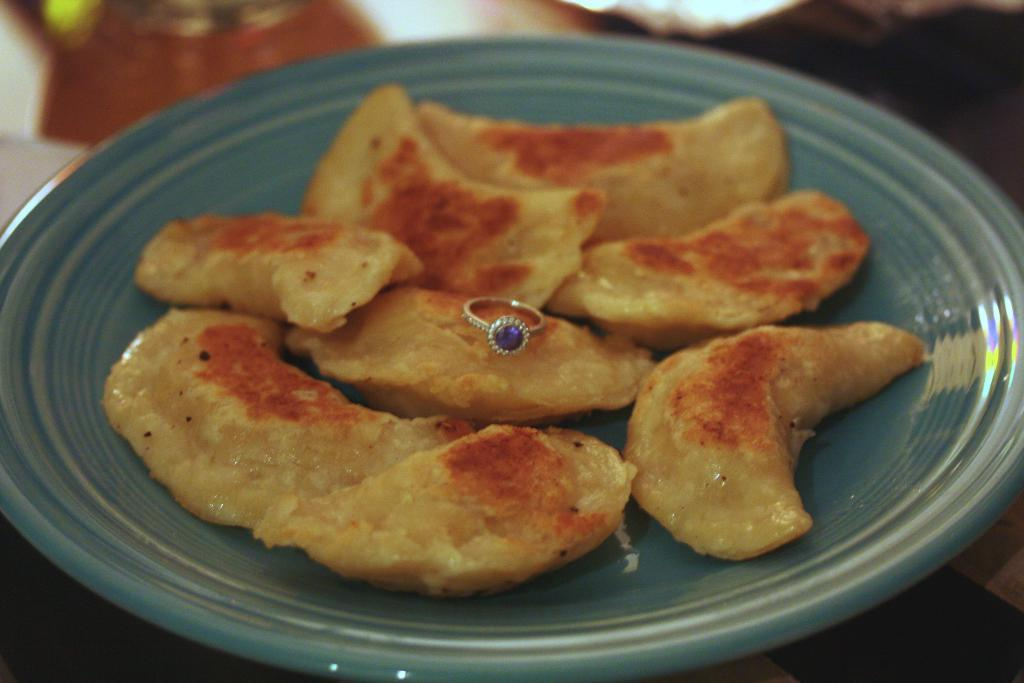What is on the plate that is visible in the image? There is a plate with food in the image. Can you describe the appearance of the food? The food has brown and orange colors. What color is the plate? The plate is green. How would you describe the background of the image? The background of the image is blurred. What type of waste is being produced by the farmer in the image? There is no farmer or waste present in the image. Which direction is the food pointing towards in the image? The food on the plate is not pointing in any direction; it is stationary. 